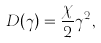Convert formula to latex. <formula><loc_0><loc_0><loc_500><loc_500>D ( \gamma ) = \frac { \chi } { 2 } \gamma ^ { 2 } ,</formula> 